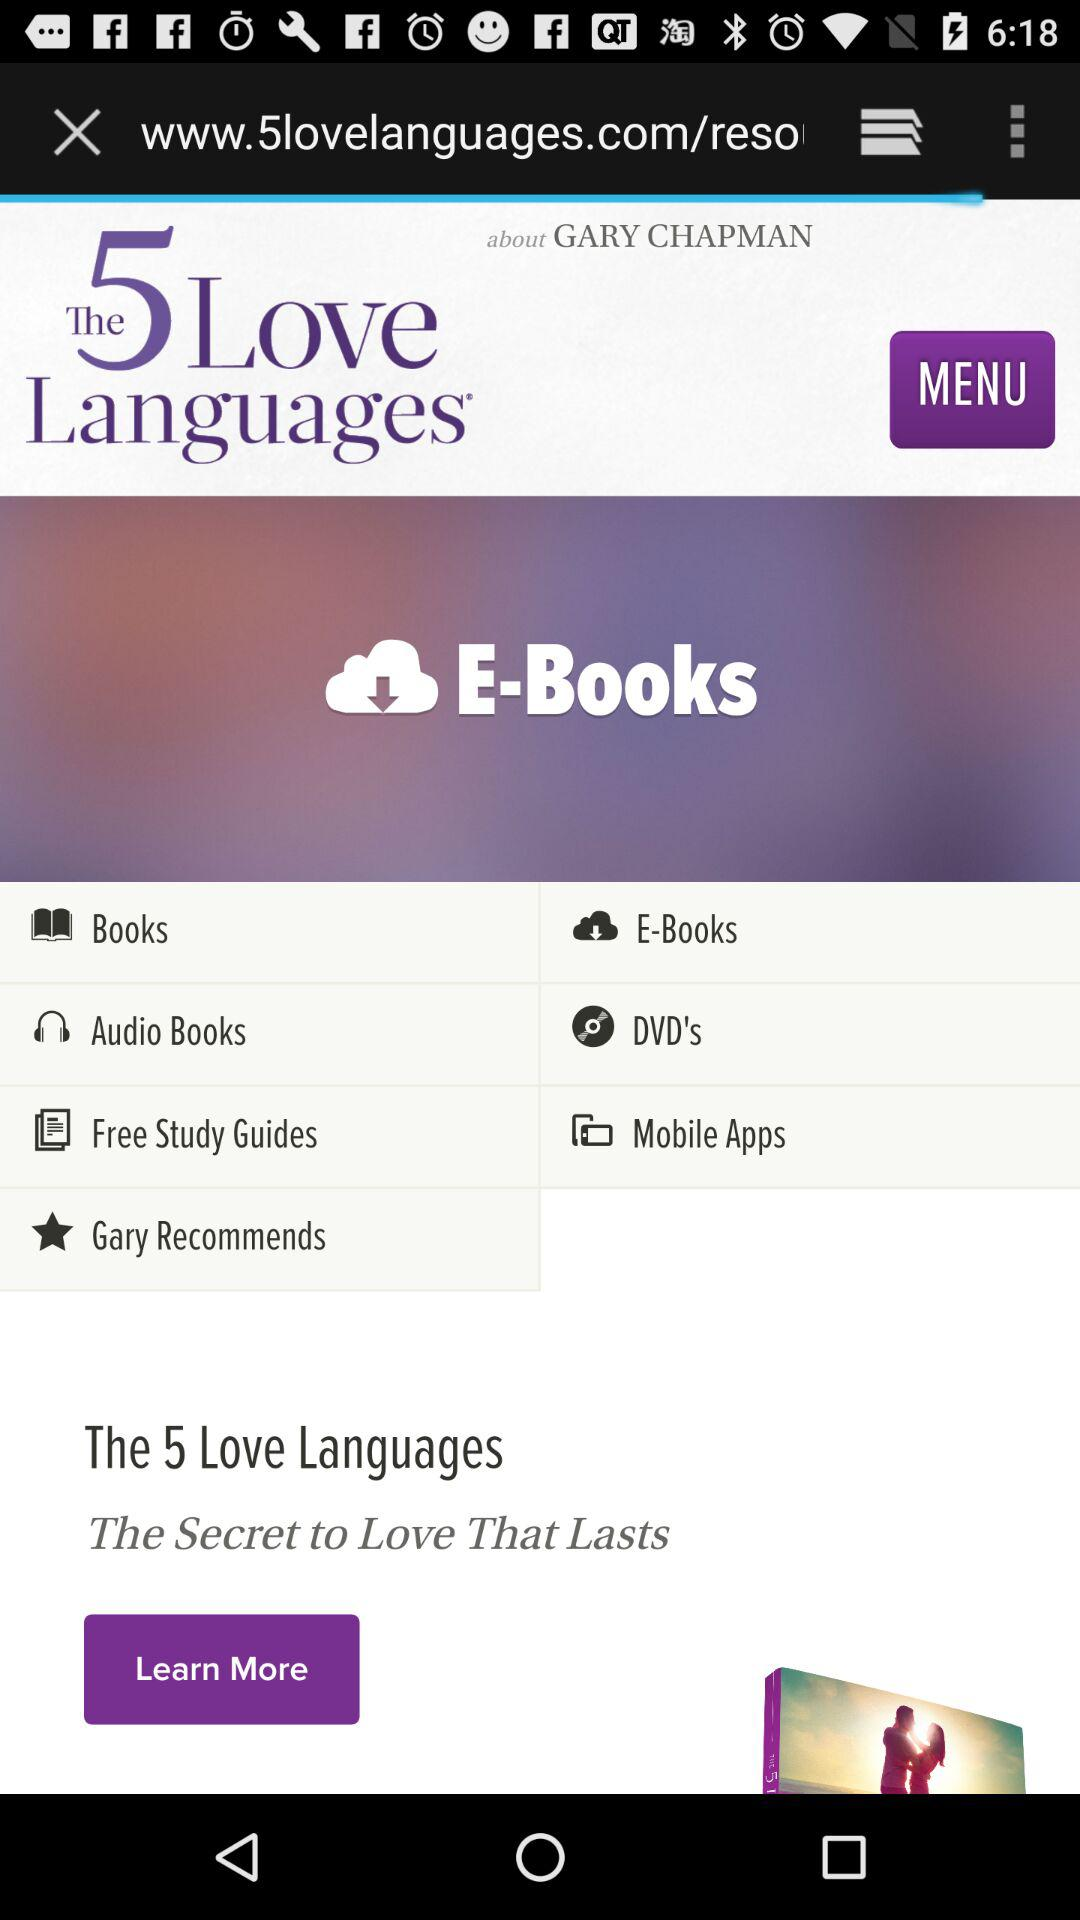What is Gary Chapman's email address?
When the provided information is insufficient, respond with <no answer>. <no answer> 